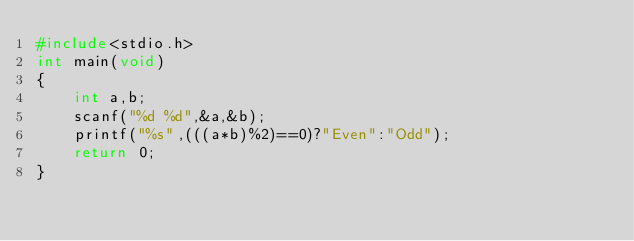<code> <loc_0><loc_0><loc_500><loc_500><_C_>#include<stdio.h>
int main(void)
{
	int a,b;
	scanf("%d %d",&a,&b);
	printf("%s",(((a*b)%2)==0)?"Even":"Odd");
	return 0;
} </code> 